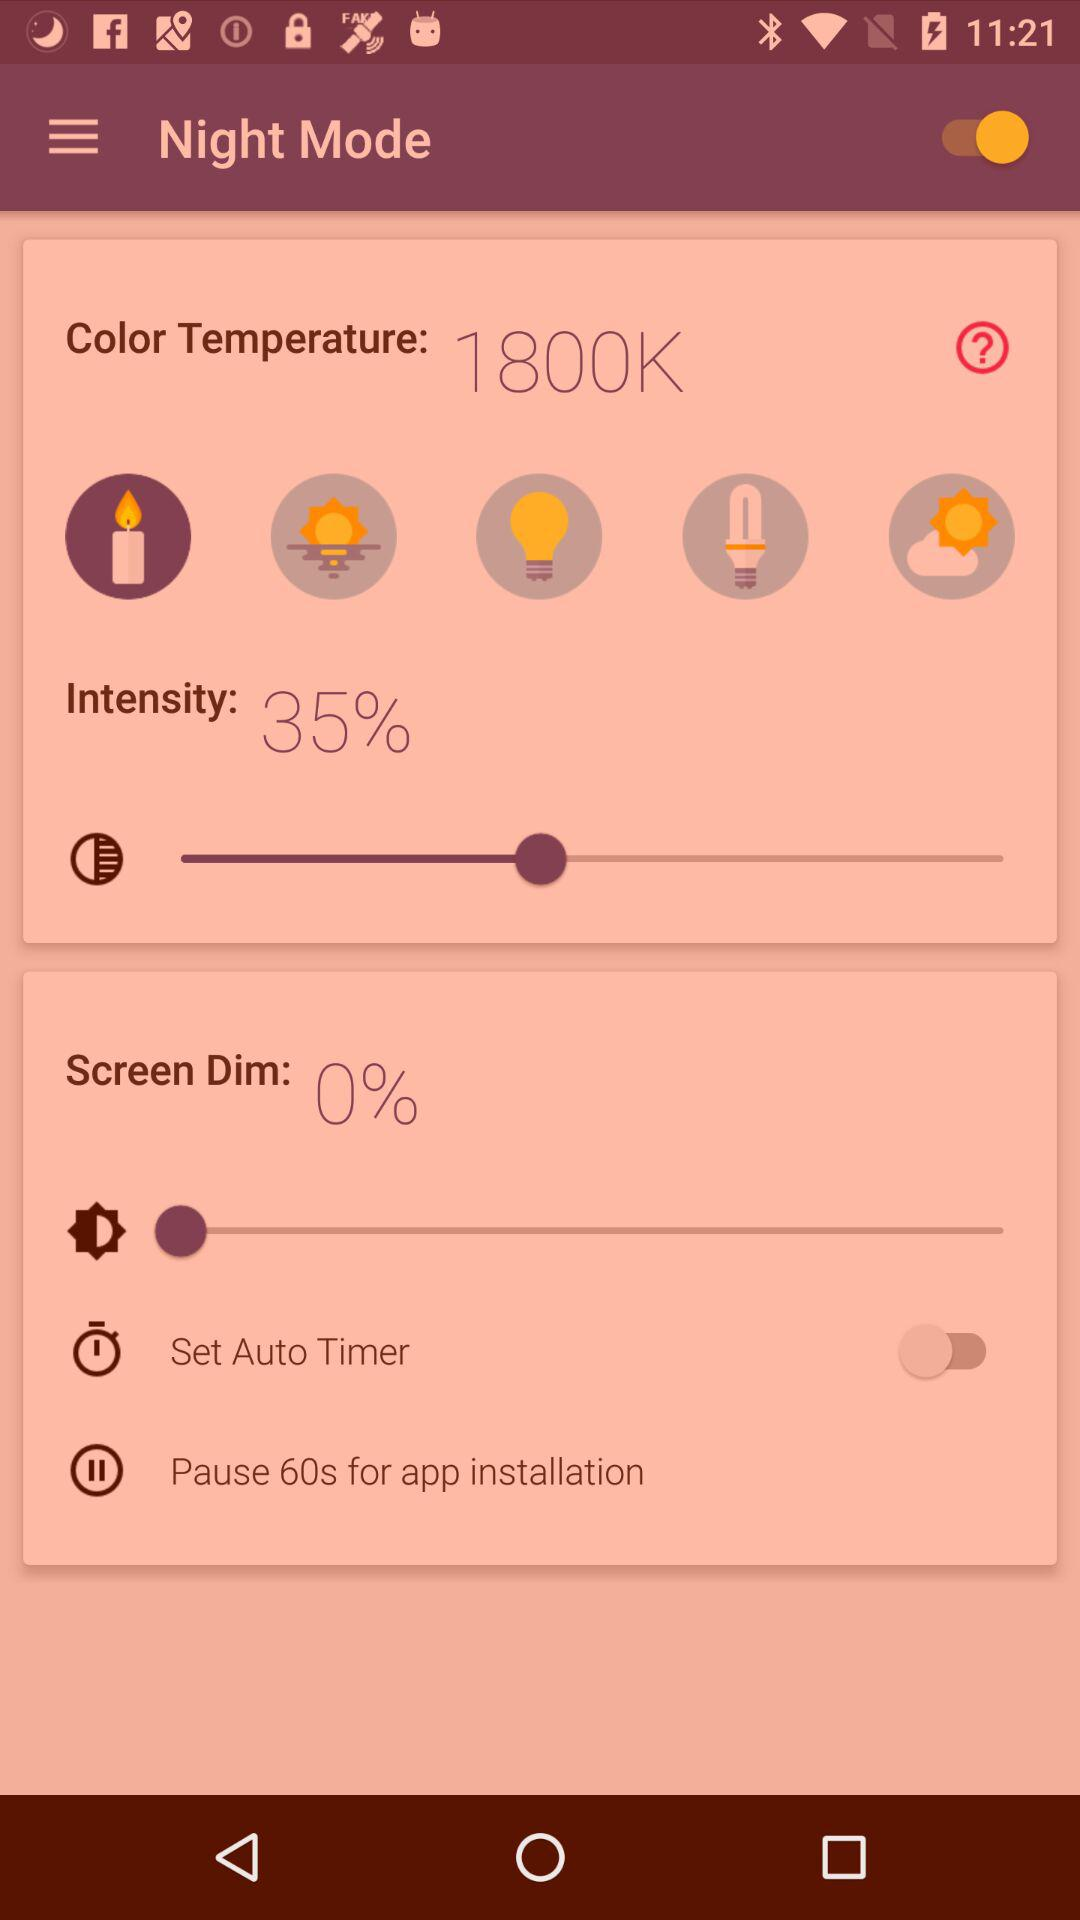What is the percentage of screen dim? The percentage of screen dim is 0. 